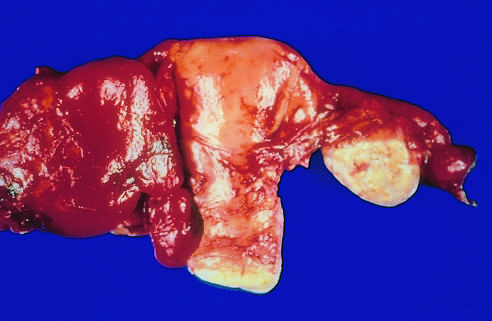what are the tube and ovary to the left of the uterus totally obscured by?
Answer the question using a single word or phrase. The hemorrhagic inflammatory mass 